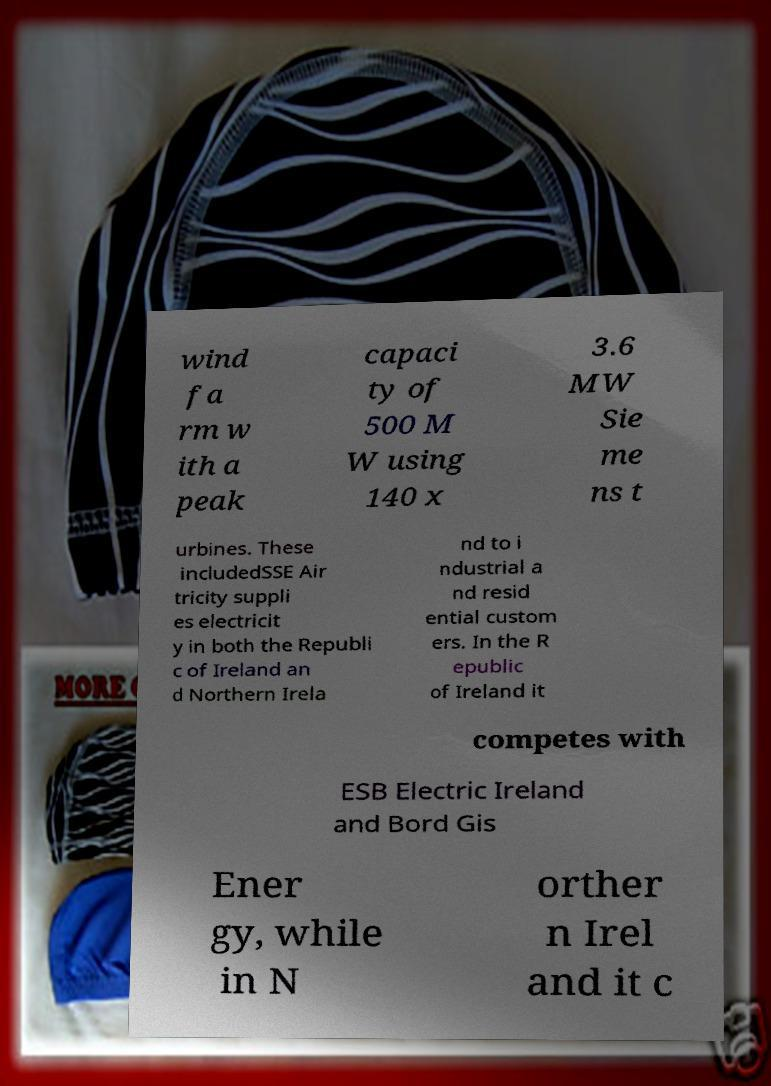For documentation purposes, I need the text within this image transcribed. Could you provide that? wind fa rm w ith a peak capaci ty of 500 M W using 140 x 3.6 MW Sie me ns t urbines. These includedSSE Air tricity suppli es electricit y in both the Republi c of Ireland an d Northern Irela nd to i ndustrial a nd resid ential custom ers. In the R epublic of Ireland it competes with ESB Electric Ireland and Bord Gis Ener gy, while in N orther n Irel and it c 